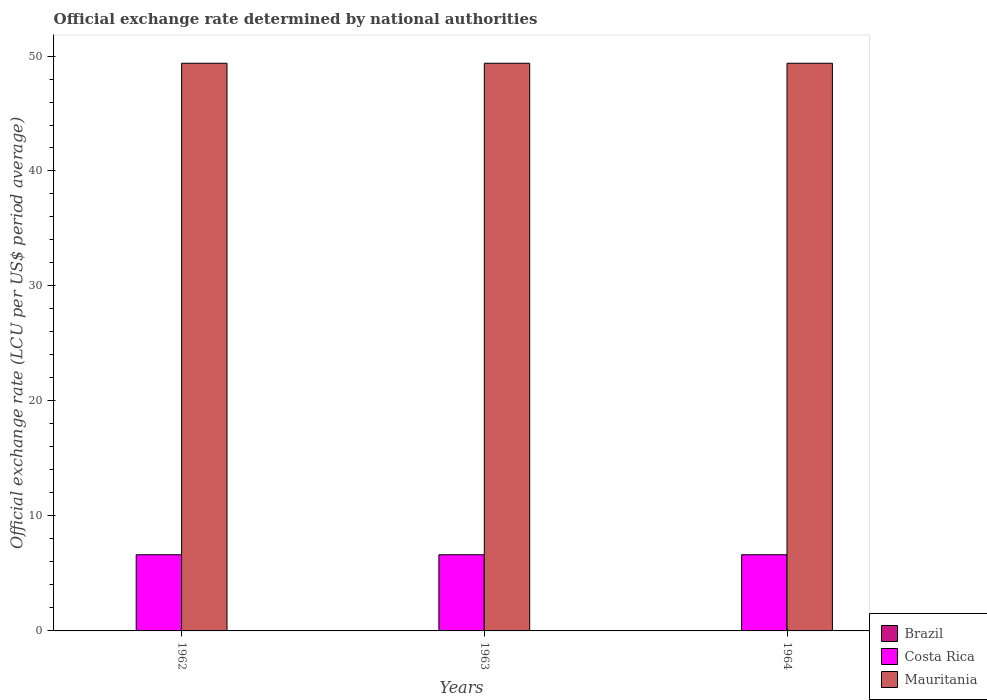Are the number of bars per tick equal to the number of legend labels?
Provide a succinct answer. Yes. How many bars are there on the 2nd tick from the right?
Your answer should be compact. 3. In how many cases, is the number of bars for a given year not equal to the number of legend labels?
Your response must be concise. 0. What is the official exchange rate in Mauritania in 1963?
Keep it short and to the point. 49.37. Across all years, what is the maximum official exchange rate in Brazil?
Keep it short and to the point. 5.42023917053559e-13. Across all years, what is the minimum official exchange rate in Mauritania?
Offer a terse response. 49.37. In which year was the official exchange rate in Costa Rica maximum?
Give a very brief answer. 1962. What is the total official exchange rate in Costa Rica in the graph?
Give a very brief answer. 19.88. What is the difference between the official exchange rate in Costa Rica in 1962 and the official exchange rate in Mauritania in 1964?
Keep it short and to the point. -42.74. What is the average official exchange rate in Brazil per year?
Keep it short and to the point. 3.195524900722833e-13. In the year 1963, what is the difference between the official exchange rate in Brazil and official exchange rate in Mauritania?
Your answer should be very brief. -49.37. What is the difference between the highest and the second highest official exchange rate in Mauritania?
Ensure brevity in your answer.  0. In how many years, is the official exchange rate in Brazil greater than the average official exchange rate in Brazil taken over all years?
Keep it short and to the point. 1. Is the sum of the official exchange rate in Brazil in 1963 and 1964 greater than the maximum official exchange rate in Costa Rica across all years?
Provide a short and direct response. No. Is it the case that in every year, the sum of the official exchange rate in Costa Rica and official exchange rate in Mauritania is greater than the official exchange rate in Brazil?
Your answer should be compact. Yes. Are all the bars in the graph horizontal?
Your response must be concise. No. How many years are there in the graph?
Ensure brevity in your answer.  3. What is the difference between two consecutive major ticks on the Y-axis?
Offer a terse response. 10. How many legend labels are there?
Ensure brevity in your answer.  3. What is the title of the graph?
Your response must be concise. Official exchange rate determined by national authorities. Does "Small states" appear as one of the legend labels in the graph?
Keep it short and to the point. No. What is the label or title of the X-axis?
Offer a very short reply. Years. What is the label or title of the Y-axis?
Your answer should be compact. Official exchange rate (LCU per US$ period average). What is the Official exchange rate (LCU per US$ period average) in Brazil in 1962?
Offer a terse response. 1.67764155487091e-13. What is the Official exchange rate (LCU per US$ period average) in Costa Rica in 1962?
Your answer should be compact. 6.63. What is the Official exchange rate (LCU per US$ period average) in Mauritania in 1962?
Offer a very short reply. 49.37. What is the Official exchange rate (LCU per US$ period average) in Brazil in 1963?
Your response must be concise. 2.488693976762e-13. What is the Official exchange rate (LCU per US$ period average) in Costa Rica in 1963?
Your response must be concise. 6.63. What is the Official exchange rate (LCU per US$ period average) in Mauritania in 1963?
Provide a succinct answer. 49.37. What is the Official exchange rate (LCU per US$ period average) in Brazil in 1964?
Provide a succinct answer. 5.42023917053559e-13. What is the Official exchange rate (LCU per US$ period average) of Costa Rica in 1964?
Offer a very short reply. 6.63. What is the Official exchange rate (LCU per US$ period average) of Mauritania in 1964?
Your response must be concise. 49.37. Across all years, what is the maximum Official exchange rate (LCU per US$ period average) in Brazil?
Offer a very short reply. 5.42023917053559e-13. Across all years, what is the maximum Official exchange rate (LCU per US$ period average) in Costa Rica?
Provide a succinct answer. 6.63. Across all years, what is the maximum Official exchange rate (LCU per US$ period average) in Mauritania?
Give a very brief answer. 49.37. Across all years, what is the minimum Official exchange rate (LCU per US$ period average) of Brazil?
Offer a very short reply. 1.67764155487091e-13. Across all years, what is the minimum Official exchange rate (LCU per US$ period average) in Costa Rica?
Your answer should be compact. 6.63. Across all years, what is the minimum Official exchange rate (LCU per US$ period average) of Mauritania?
Your answer should be very brief. 49.37. What is the total Official exchange rate (LCU per US$ period average) in Costa Rica in the graph?
Offer a terse response. 19.88. What is the total Official exchange rate (LCU per US$ period average) in Mauritania in the graph?
Provide a short and direct response. 148.11. What is the difference between the Official exchange rate (LCU per US$ period average) of Brazil in 1962 and that in 1963?
Offer a terse response. -0. What is the difference between the Official exchange rate (LCU per US$ period average) of Costa Rica in 1962 and that in 1963?
Your answer should be compact. 0. What is the difference between the Official exchange rate (LCU per US$ period average) of Brazil in 1963 and that in 1964?
Keep it short and to the point. -0. What is the difference between the Official exchange rate (LCU per US$ period average) in Costa Rica in 1963 and that in 1964?
Your answer should be compact. 0. What is the difference between the Official exchange rate (LCU per US$ period average) in Brazil in 1962 and the Official exchange rate (LCU per US$ period average) in Costa Rica in 1963?
Offer a very short reply. -6.62. What is the difference between the Official exchange rate (LCU per US$ period average) of Brazil in 1962 and the Official exchange rate (LCU per US$ period average) of Mauritania in 1963?
Give a very brief answer. -49.37. What is the difference between the Official exchange rate (LCU per US$ period average) of Costa Rica in 1962 and the Official exchange rate (LCU per US$ period average) of Mauritania in 1963?
Your answer should be very brief. -42.74. What is the difference between the Official exchange rate (LCU per US$ period average) of Brazil in 1962 and the Official exchange rate (LCU per US$ period average) of Costa Rica in 1964?
Ensure brevity in your answer.  -6.62. What is the difference between the Official exchange rate (LCU per US$ period average) in Brazil in 1962 and the Official exchange rate (LCU per US$ period average) in Mauritania in 1964?
Offer a terse response. -49.37. What is the difference between the Official exchange rate (LCU per US$ period average) of Costa Rica in 1962 and the Official exchange rate (LCU per US$ period average) of Mauritania in 1964?
Provide a short and direct response. -42.74. What is the difference between the Official exchange rate (LCU per US$ period average) in Brazil in 1963 and the Official exchange rate (LCU per US$ period average) in Costa Rica in 1964?
Your answer should be compact. -6.62. What is the difference between the Official exchange rate (LCU per US$ period average) of Brazil in 1963 and the Official exchange rate (LCU per US$ period average) of Mauritania in 1964?
Offer a very short reply. -49.37. What is the difference between the Official exchange rate (LCU per US$ period average) of Costa Rica in 1963 and the Official exchange rate (LCU per US$ period average) of Mauritania in 1964?
Your response must be concise. -42.74. What is the average Official exchange rate (LCU per US$ period average) in Brazil per year?
Keep it short and to the point. 0. What is the average Official exchange rate (LCU per US$ period average) in Costa Rica per year?
Offer a very short reply. 6.62. What is the average Official exchange rate (LCU per US$ period average) of Mauritania per year?
Ensure brevity in your answer.  49.37. In the year 1962, what is the difference between the Official exchange rate (LCU per US$ period average) of Brazil and Official exchange rate (LCU per US$ period average) of Costa Rica?
Offer a very short reply. -6.62. In the year 1962, what is the difference between the Official exchange rate (LCU per US$ period average) in Brazil and Official exchange rate (LCU per US$ period average) in Mauritania?
Ensure brevity in your answer.  -49.37. In the year 1962, what is the difference between the Official exchange rate (LCU per US$ period average) of Costa Rica and Official exchange rate (LCU per US$ period average) of Mauritania?
Your response must be concise. -42.74. In the year 1963, what is the difference between the Official exchange rate (LCU per US$ period average) of Brazil and Official exchange rate (LCU per US$ period average) of Costa Rica?
Ensure brevity in your answer.  -6.62. In the year 1963, what is the difference between the Official exchange rate (LCU per US$ period average) in Brazil and Official exchange rate (LCU per US$ period average) in Mauritania?
Provide a short and direct response. -49.37. In the year 1963, what is the difference between the Official exchange rate (LCU per US$ period average) in Costa Rica and Official exchange rate (LCU per US$ period average) in Mauritania?
Offer a very short reply. -42.74. In the year 1964, what is the difference between the Official exchange rate (LCU per US$ period average) of Brazil and Official exchange rate (LCU per US$ period average) of Costa Rica?
Your answer should be very brief. -6.62. In the year 1964, what is the difference between the Official exchange rate (LCU per US$ period average) of Brazil and Official exchange rate (LCU per US$ period average) of Mauritania?
Keep it short and to the point. -49.37. In the year 1964, what is the difference between the Official exchange rate (LCU per US$ period average) in Costa Rica and Official exchange rate (LCU per US$ period average) in Mauritania?
Keep it short and to the point. -42.74. What is the ratio of the Official exchange rate (LCU per US$ period average) in Brazil in 1962 to that in 1963?
Ensure brevity in your answer.  0.67. What is the ratio of the Official exchange rate (LCU per US$ period average) of Costa Rica in 1962 to that in 1963?
Your answer should be compact. 1. What is the ratio of the Official exchange rate (LCU per US$ period average) in Mauritania in 1962 to that in 1963?
Your answer should be very brief. 1. What is the ratio of the Official exchange rate (LCU per US$ period average) of Brazil in 1962 to that in 1964?
Provide a short and direct response. 0.31. What is the ratio of the Official exchange rate (LCU per US$ period average) in Costa Rica in 1962 to that in 1964?
Provide a short and direct response. 1. What is the ratio of the Official exchange rate (LCU per US$ period average) in Mauritania in 1962 to that in 1964?
Ensure brevity in your answer.  1. What is the ratio of the Official exchange rate (LCU per US$ period average) of Brazil in 1963 to that in 1964?
Make the answer very short. 0.46. What is the difference between the highest and the second highest Official exchange rate (LCU per US$ period average) of Brazil?
Provide a short and direct response. 0. What is the difference between the highest and the second highest Official exchange rate (LCU per US$ period average) in Mauritania?
Your answer should be very brief. 0. What is the difference between the highest and the lowest Official exchange rate (LCU per US$ period average) in Brazil?
Give a very brief answer. 0. What is the difference between the highest and the lowest Official exchange rate (LCU per US$ period average) of Costa Rica?
Keep it short and to the point. 0. What is the difference between the highest and the lowest Official exchange rate (LCU per US$ period average) of Mauritania?
Your answer should be very brief. 0. 